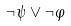Convert formula to latex. <formula><loc_0><loc_0><loc_500><loc_500>\neg \psi \vee \neg \varphi</formula> 